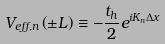<formula> <loc_0><loc_0><loc_500><loc_500>V _ { e f f , n } \left ( \pm L \right ) \equiv - \frac { t _ { h } } { 2 } e ^ { i K _ { n } \Delta x }</formula> 